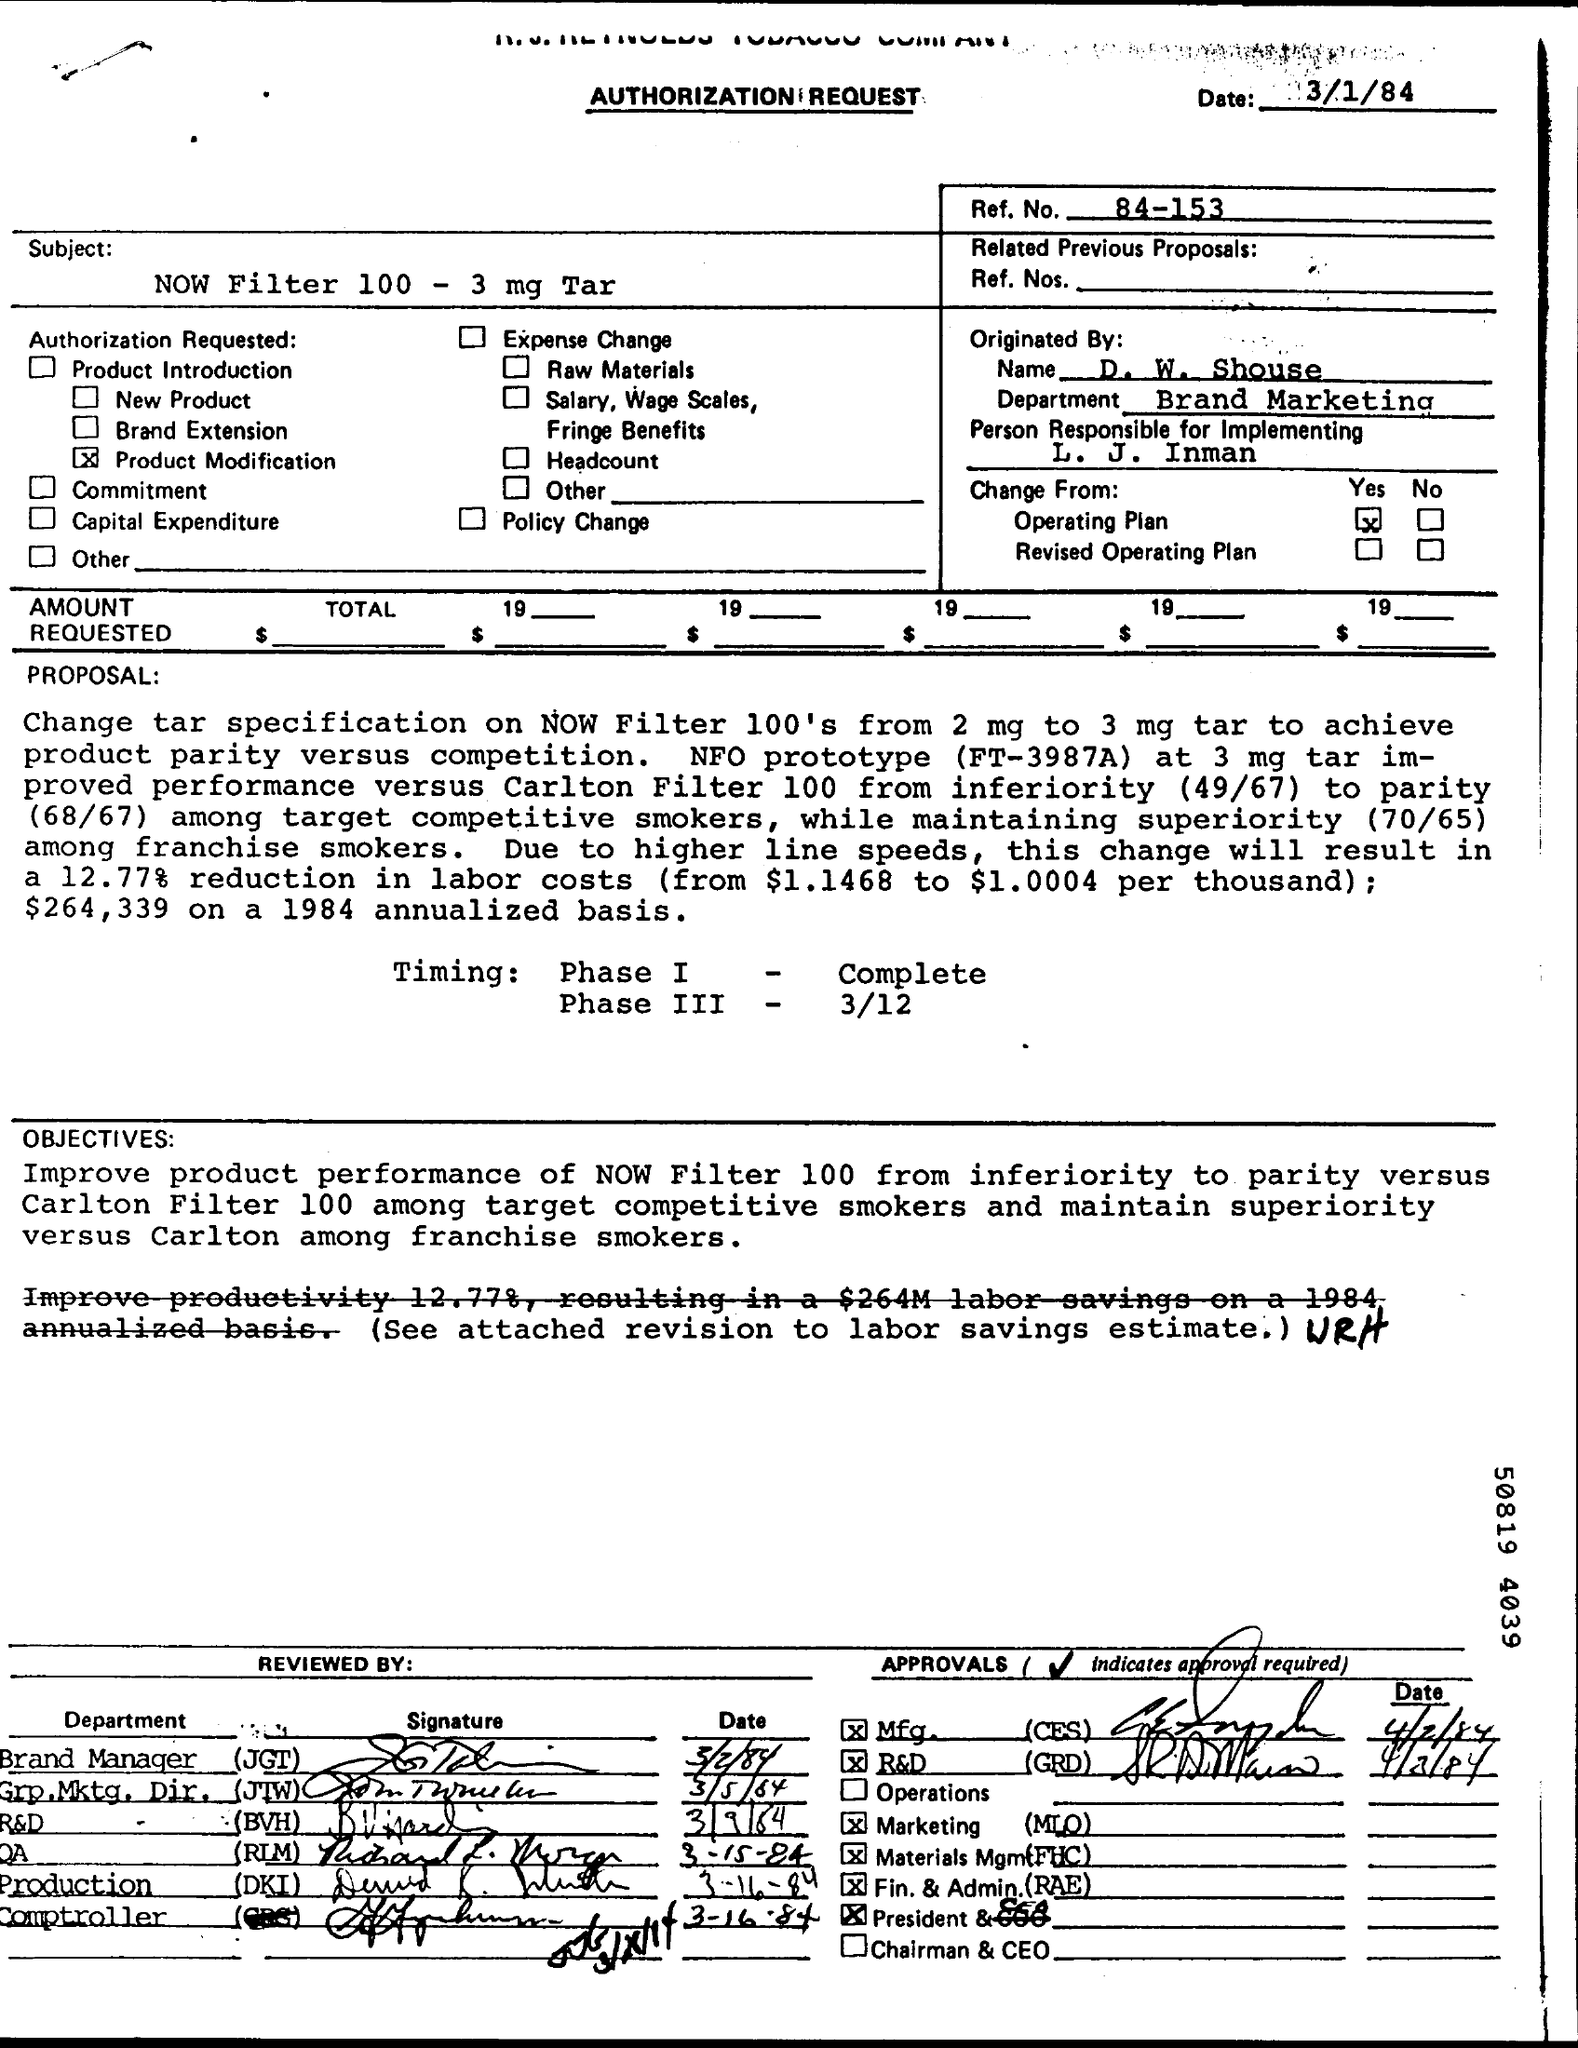What is the issued date of this document?
Provide a succinct answer. 3/1/84. What is the Ref. No. mentioned in this document?
Ensure brevity in your answer.  84-153. What is the Subject mentioned in the Authorization Request?
Give a very brief answer. NOW Filter 100 - 3 mg Tar. What is the timing of Phase III given?
Keep it short and to the point. 3/12. What is the timing of Phase I given?
Your answer should be very brief. Complete. 